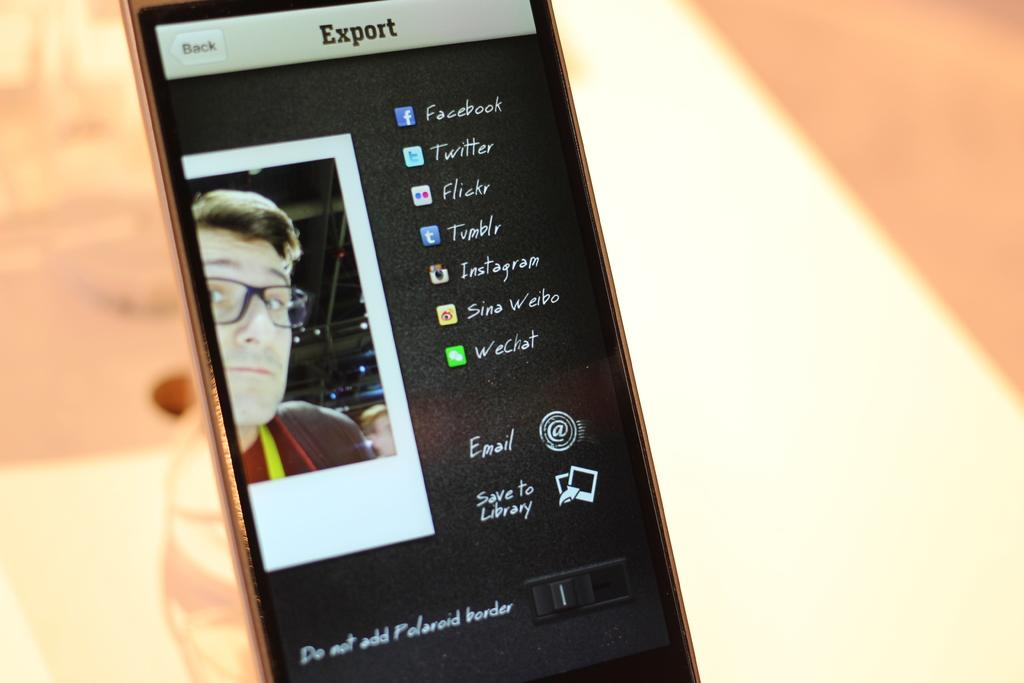<image>
Offer a succinct explanation of the picture presented. A phone screen allowing the user to export a picture to Facebook, Twitter, Flickr, and other social media sites. 